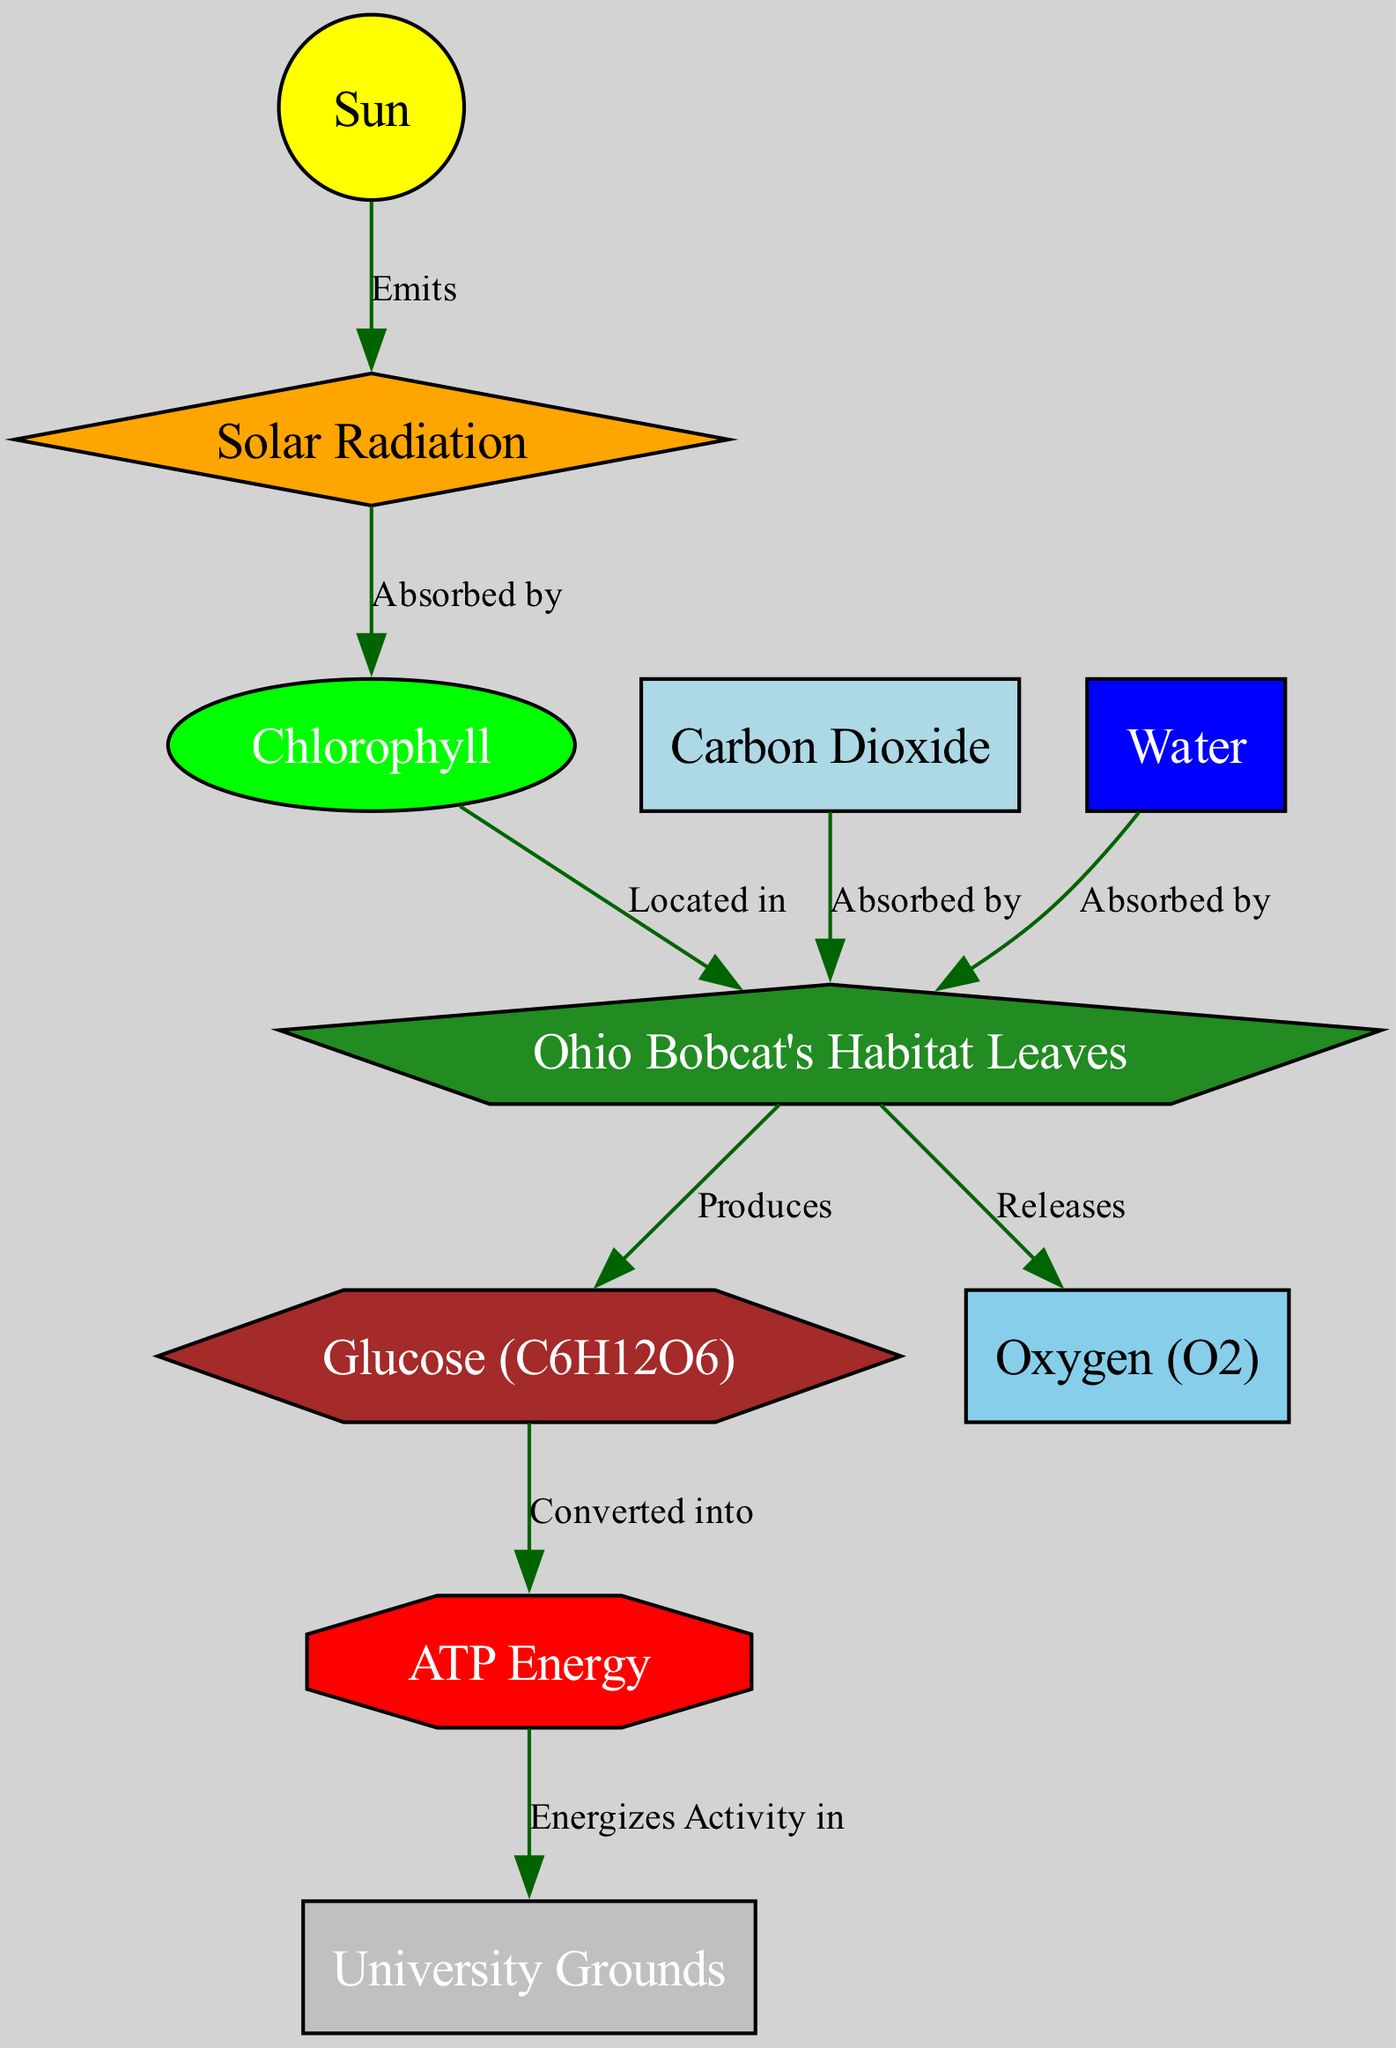What is the main source of energy in the diagram? The diagram indicates that the main source of energy is the "Sun," which emits solar radiation that is essential for the photosynthetic process.
Answer: Sun How many nodes are present in the diagram? Counting all unique entities in the diagram, there are 10 nodes listed, including entities like Sun, leaves, and glucose.
Answer: 10 What do leaves produce during photosynthesis? According to the diagram, leaves are responsible for producing glucose and releasing oxygen during the photosynthetic process.
Answer: Glucose (C6H12O6) and Oxygen (O2) Which molecule is absorbed by leaves along with sunlight? The diagram specifies that both "Carbon Dioxide" and "Water" are absorbed by leaves to facilitate the production processes.
Answer: Carbon Dioxide and Water What is glucose converted into for energy use? The flow from glucose indicates that it is converted into "ATP Energy," which is utilized in activity throughout the diagram.
Answer: ATP Energy Where is chlorophyll located in this process? The diagram explicitly states that chlorophyll is "Located in" the leaves, emphasizing the role of chlorophyll in photosynthesis.
Answer: Leaves How does ATP energy relate to the basketball court? The diagram shows a direct connection indicating that ATP energizes activity in the "Basketball Court" on the university grounds.
Answer: Energizes Activity in University Grounds What role does water play in the photosynthetic process? The diagram illustrates that water is absorbed by leaves and is essential for producing glucose and oxygen, thus indicating its crucial role.
Answer: Absorbed by leaves What color signifies oxygen in the diagram? The diagram employs a "skyblue" color to depict oxygen, differentiating it visually from other components.
Answer: Skyblue What does solar radiation get absorbed by? According to the diagram, solar radiation is absorbed by chlorophyll, which enables the photosynthetic process to begin.
Answer: Chlorophyll 